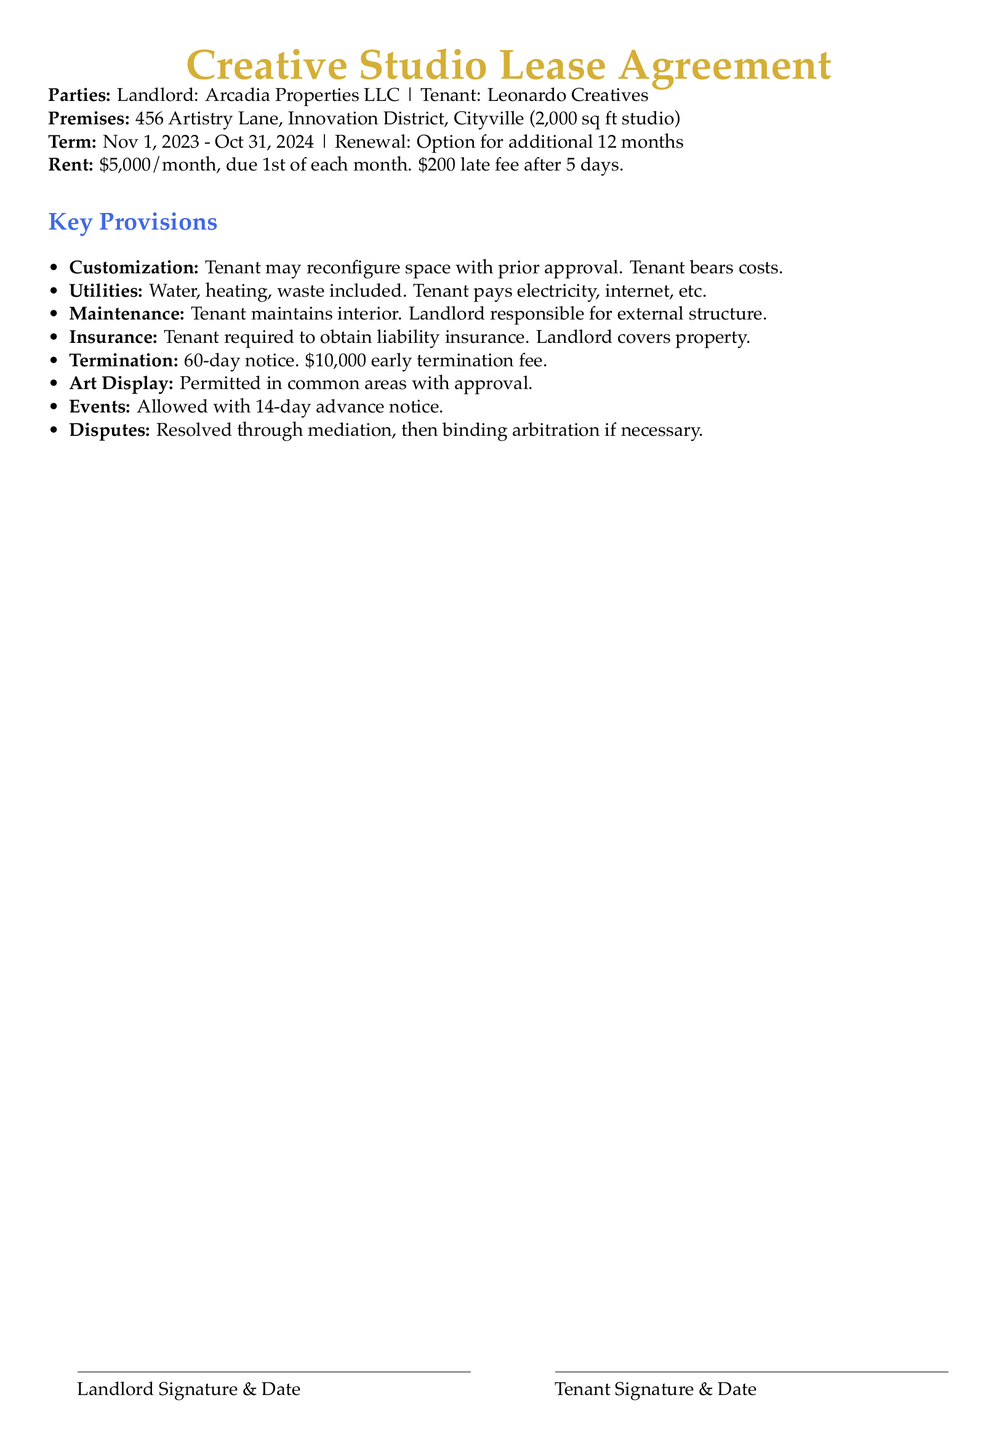What is the name of the landlord? The landlord’s name is specified in the document, which is Arcadia Properties LLC.
Answer: Arcadia Properties LLC What is the monthly rent amount? The document states that the monthly rent is $5,000, which is clearly indicated in the rent section.
Answer: $5,000 What is the duration of the lease term? The lease term starts on November 1, 2023, and ends on October 31, 2024, as mentioned in the term section.
Answer: Nov 1, 2023 - Oct 31, 2024 What fee is charged for late rent payments? The lease agreement outlines a late fee of $200 after 5 days of non-payment.
Answer: $200 What is required for customization of the studio space? The tenant must obtain prior approval for any customization, which is noted in the customization section.
Answer: Prior approval What type of insurance must the tenant obtain? The document specifies that the tenant is required to obtain liability insurance.
Answer: Liability insurance How much notice is required for lease termination? It is stated that a 60-day notice is required for terminating the lease.
Answer: 60-day notice What is the fee for early termination of the lease? The lease clearly states that there is a $10,000 fee for early termination.
Answer: $10,000 How much notice is needed to host an event? The document mentions that a 14-day advance notice is required to hold an event.
Answer: 14-day advance notice 